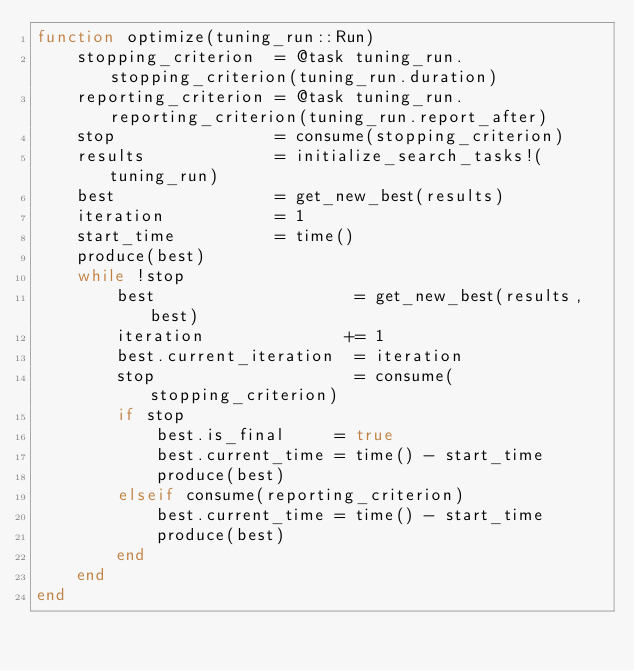<code> <loc_0><loc_0><loc_500><loc_500><_Julia_>function optimize(tuning_run::Run)
    stopping_criterion  = @task tuning_run.stopping_criterion(tuning_run.duration)
    reporting_criterion = @task tuning_run.reporting_criterion(tuning_run.report_after)
    stop                = consume(stopping_criterion)
    results             = initialize_search_tasks!(tuning_run)
    best                = get_new_best(results)
    iteration           = 1
    start_time          = time()
    produce(best)
    while !stop
        best                    = get_new_best(results, best)
        iteration              += 1
        best.current_iteration  = iteration
        stop                    = consume(stopping_criterion)
        if stop
            best.is_final     = true
            best.current_time = time() - start_time
            produce(best)
        elseif consume(reporting_criterion)
            best.current_time = time() - start_time
            produce(best)
        end
    end
end
</code> 